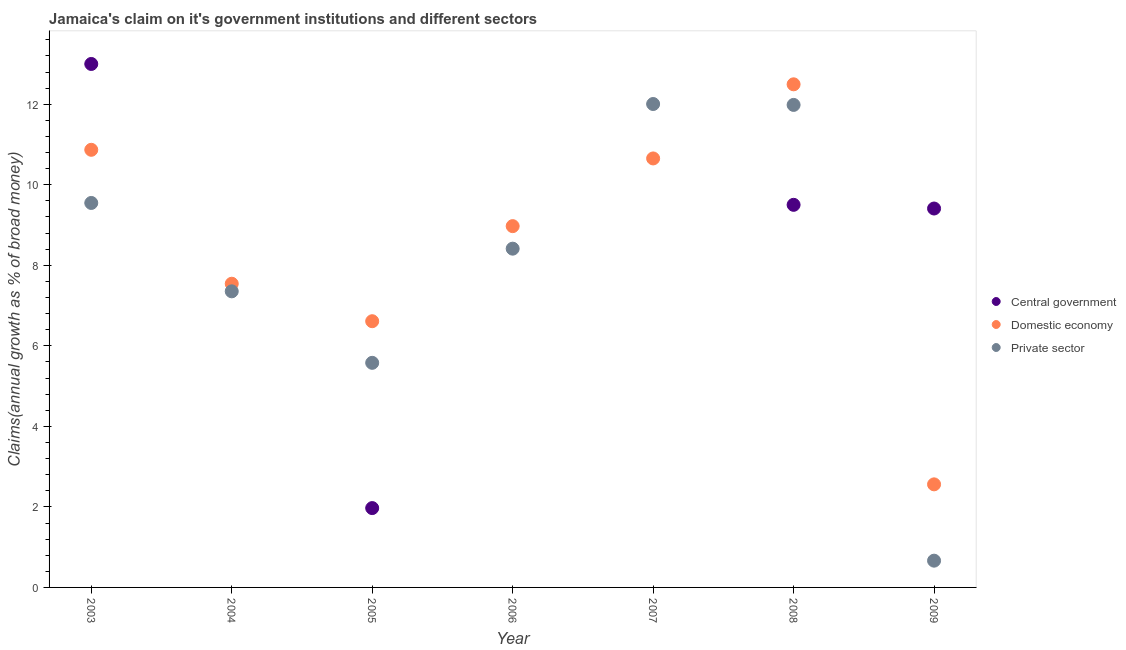Is the number of dotlines equal to the number of legend labels?
Your response must be concise. No. Across all years, what is the maximum percentage of claim on the domestic economy?
Provide a succinct answer. 12.49. Across all years, what is the minimum percentage of claim on the private sector?
Keep it short and to the point. 0.66. In which year was the percentage of claim on the private sector maximum?
Keep it short and to the point. 2007. What is the total percentage of claim on the central government in the graph?
Your response must be concise. 33.88. What is the difference between the percentage of claim on the private sector in 2004 and that in 2007?
Give a very brief answer. -4.65. What is the difference between the percentage of claim on the central government in 2009 and the percentage of claim on the private sector in 2008?
Your answer should be very brief. -2.57. What is the average percentage of claim on the private sector per year?
Give a very brief answer. 7.94. In the year 2008, what is the difference between the percentage of claim on the domestic economy and percentage of claim on the private sector?
Give a very brief answer. 0.51. In how many years, is the percentage of claim on the central government greater than 0.4 %?
Provide a short and direct response. 4. What is the ratio of the percentage of claim on the private sector in 2007 to that in 2008?
Your response must be concise. 1. Is the difference between the percentage of claim on the private sector in 2004 and 2007 greater than the difference between the percentage of claim on the domestic economy in 2004 and 2007?
Offer a very short reply. No. What is the difference between the highest and the second highest percentage of claim on the central government?
Offer a very short reply. 3.5. What is the difference between the highest and the lowest percentage of claim on the private sector?
Offer a terse response. 11.34. In how many years, is the percentage of claim on the domestic economy greater than the average percentage of claim on the domestic economy taken over all years?
Make the answer very short. 4. Is the sum of the percentage of claim on the domestic economy in 2006 and 2007 greater than the maximum percentage of claim on the central government across all years?
Make the answer very short. Yes. Is it the case that in every year, the sum of the percentage of claim on the central government and percentage of claim on the domestic economy is greater than the percentage of claim on the private sector?
Your response must be concise. No. Is the percentage of claim on the private sector strictly less than the percentage of claim on the central government over the years?
Your answer should be compact. No. How many years are there in the graph?
Give a very brief answer. 7. Are the values on the major ticks of Y-axis written in scientific E-notation?
Your answer should be compact. No. Does the graph contain any zero values?
Your answer should be compact. Yes. Does the graph contain grids?
Offer a very short reply. No. Where does the legend appear in the graph?
Make the answer very short. Center right. How are the legend labels stacked?
Your answer should be very brief. Vertical. What is the title of the graph?
Provide a succinct answer. Jamaica's claim on it's government institutions and different sectors. Does "Argument" appear as one of the legend labels in the graph?
Your answer should be compact. No. What is the label or title of the Y-axis?
Offer a terse response. Claims(annual growth as % of broad money). What is the Claims(annual growth as % of broad money) in Central government in 2003?
Your response must be concise. 13. What is the Claims(annual growth as % of broad money) of Domestic economy in 2003?
Offer a very short reply. 10.87. What is the Claims(annual growth as % of broad money) of Private sector in 2003?
Make the answer very short. 9.55. What is the Claims(annual growth as % of broad money) in Central government in 2004?
Make the answer very short. 0. What is the Claims(annual growth as % of broad money) of Domestic economy in 2004?
Make the answer very short. 7.54. What is the Claims(annual growth as % of broad money) in Private sector in 2004?
Ensure brevity in your answer.  7.35. What is the Claims(annual growth as % of broad money) in Central government in 2005?
Offer a very short reply. 1.97. What is the Claims(annual growth as % of broad money) of Domestic economy in 2005?
Provide a short and direct response. 6.61. What is the Claims(annual growth as % of broad money) in Private sector in 2005?
Your response must be concise. 5.58. What is the Claims(annual growth as % of broad money) of Domestic economy in 2006?
Give a very brief answer. 8.97. What is the Claims(annual growth as % of broad money) of Private sector in 2006?
Your answer should be compact. 8.41. What is the Claims(annual growth as % of broad money) of Domestic economy in 2007?
Provide a succinct answer. 10.65. What is the Claims(annual growth as % of broad money) of Private sector in 2007?
Make the answer very short. 12.01. What is the Claims(annual growth as % of broad money) in Central government in 2008?
Make the answer very short. 9.5. What is the Claims(annual growth as % of broad money) of Domestic economy in 2008?
Your answer should be very brief. 12.49. What is the Claims(annual growth as % of broad money) in Private sector in 2008?
Your answer should be compact. 11.98. What is the Claims(annual growth as % of broad money) in Central government in 2009?
Your answer should be compact. 9.41. What is the Claims(annual growth as % of broad money) of Domestic economy in 2009?
Provide a succinct answer. 2.56. What is the Claims(annual growth as % of broad money) of Private sector in 2009?
Provide a succinct answer. 0.66. Across all years, what is the maximum Claims(annual growth as % of broad money) of Central government?
Keep it short and to the point. 13. Across all years, what is the maximum Claims(annual growth as % of broad money) of Domestic economy?
Your answer should be compact. 12.49. Across all years, what is the maximum Claims(annual growth as % of broad money) of Private sector?
Your response must be concise. 12.01. Across all years, what is the minimum Claims(annual growth as % of broad money) of Central government?
Give a very brief answer. 0. Across all years, what is the minimum Claims(annual growth as % of broad money) in Domestic economy?
Offer a very short reply. 2.56. Across all years, what is the minimum Claims(annual growth as % of broad money) of Private sector?
Ensure brevity in your answer.  0.66. What is the total Claims(annual growth as % of broad money) in Central government in the graph?
Your answer should be compact. 33.88. What is the total Claims(annual growth as % of broad money) of Domestic economy in the graph?
Provide a short and direct response. 59.7. What is the total Claims(annual growth as % of broad money) in Private sector in the graph?
Provide a succinct answer. 55.55. What is the difference between the Claims(annual growth as % of broad money) of Domestic economy in 2003 and that in 2004?
Your response must be concise. 3.33. What is the difference between the Claims(annual growth as % of broad money) in Private sector in 2003 and that in 2004?
Your answer should be compact. 2.19. What is the difference between the Claims(annual growth as % of broad money) of Central government in 2003 and that in 2005?
Keep it short and to the point. 11.03. What is the difference between the Claims(annual growth as % of broad money) in Domestic economy in 2003 and that in 2005?
Offer a terse response. 4.26. What is the difference between the Claims(annual growth as % of broad money) of Private sector in 2003 and that in 2005?
Give a very brief answer. 3.97. What is the difference between the Claims(annual growth as % of broad money) of Domestic economy in 2003 and that in 2006?
Your answer should be compact. 1.9. What is the difference between the Claims(annual growth as % of broad money) of Private sector in 2003 and that in 2006?
Give a very brief answer. 1.14. What is the difference between the Claims(annual growth as % of broad money) of Domestic economy in 2003 and that in 2007?
Ensure brevity in your answer.  0.21. What is the difference between the Claims(annual growth as % of broad money) of Private sector in 2003 and that in 2007?
Offer a very short reply. -2.46. What is the difference between the Claims(annual growth as % of broad money) of Central government in 2003 and that in 2008?
Your response must be concise. 3.5. What is the difference between the Claims(annual growth as % of broad money) of Domestic economy in 2003 and that in 2008?
Offer a terse response. -1.63. What is the difference between the Claims(annual growth as % of broad money) of Private sector in 2003 and that in 2008?
Ensure brevity in your answer.  -2.43. What is the difference between the Claims(annual growth as % of broad money) in Central government in 2003 and that in 2009?
Your answer should be compact. 3.59. What is the difference between the Claims(annual growth as % of broad money) in Domestic economy in 2003 and that in 2009?
Provide a succinct answer. 8.31. What is the difference between the Claims(annual growth as % of broad money) in Private sector in 2003 and that in 2009?
Offer a very short reply. 8.88. What is the difference between the Claims(annual growth as % of broad money) of Domestic economy in 2004 and that in 2005?
Make the answer very short. 0.93. What is the difference between the Claims(annual growth as % of broad money) of Private sector in 2004 and that in 2005?
Your answer should be compact. 1.78. What is the difference between the Claims(annual growth as % of broad money) of Domestic economy in 2004 and that in 2006?
Keep it short and to the point. -1.43. What is the difference between the Claims(annual growth as % of broad money) in Private sector in 2004 and that in 2006?
Offer a very short reply. -1.06. What is the difference between the Claims(annual growth as % of broad money) of Domestic economy in 2004 and that in 2007?
Provide a succinct answer. -3.11. What is the difference between the Claims(annual growth as % of broad money) of Private sector in 2004 and that in 2007?
Your response must be concise. -4.65. What is the difference between the Claims(annual growth as % of broad money) of Domestic economy in 2004 and that in 2008?
Provide a short and direct response. -4.95. What is the difference between the Claims(annual growth as % of broad money) in Private sector in 2004 and that in 2008?
Provide a succinct answer. -4.63. What is the difference between the Claims(annual growth as % of broad money) of Domestic economy in 2004 and that in 2009?
Offer a terse response. 4.98. What is the difference between the Claims(annual growth as % of broad money) in Private sector in 2004 and that in 2009?
Offer a very short reply. 6.69. What is the difference between the Claims(annual growth as % of broad money) of Domestic economy in 2005 and that in 2006?
Your response must be concise. -2.36. What is the difference between the Claims(annual growth as % of broad money) in Private sector in 2005 and that in 2006?
Make the answer very short. -2.84. What is the difference between the Claims(annual growth as % of broad money) in Domestic economy in 2005 and that in 2007?
Keep it short and to the point. -4.04. What is the difference between the Claims(annual growth as % of broad money) of Private sector in 2005 and that in 2007?
Make the answer very short. -6.43. What is the difference between the Claims(annual growth as % of broad money) of Central government in 2005 and that in 2008?
Offer a terse response. -7.53. What is the difference between the Claims(annual growth as % of broad money) in Domestic economy in 2005 and that in 2008?
Your answer should be compact. -5.88. What is the difference between the Claims(annual growth as % of broad money) in Private sector in 2005 and that in 2008?
Your answer should be compact. -6.41. What is the difference between the Claims(annual growth as % of broad money) in Central government in 2005 and that in 2009?
Offer a very short reply. -7.44. What is the difference between the Claims(annual growth as % of broad money) in Domestic economy in 2005 and that in 2009?
Provide a succinct answer. 4.05. What is the difference between the Claims(annual growth as % of broad money) of Private sector in 2005 and that in 2009?
Offer a terse response. 4.91. What is the difference between the Claims(annual growth as % of broad money) in Domestic economy in 2006 and that in 2007?
Make the answer very short. -1.68. What is the difference between the Claims(annual growth as % of broad money) in Private sector in 2006 and that in 2007?
Offer a terse response. -3.59. What is the difference between the Claims(annual growth as % of broad money) of Domestic economy in 2006 and that in 2008?
Ensure brevity in your answer.  -3.52. What is the difference between the Claims(annual growth as % of broad money) of Private sector in 2006 and that in 2008?
Provide a short and direct response. -3.57. What is the difference between the Claims(annual growth as % of broad money) of Domestic economy in 2006 and that in 2009?
Give a very brief answer. 6.41. What is the difference between the Claims(annual growth as % of broad money) in Private sector in 2006 and that in 2009?
Make the answer very short. 7.75. What is the difference between the Claims(annual growth as % of broad money) in Domestic economy in 2007 and that in 2008?
Provide a short and direct response. -1.84. What is the difference between the Claims(annual growth as % of broad money) of Private sector in 2007 and that in 2008?
Offer a terse response. 0.02. What is the difference between the Claims(annual growth as % of broad money) of Domestic economy in 2007 and that in 2009?
Keep it short and to the point. 8.09. What is the difference between the Claims(annual growth as % of broad money) in Private sector in 2007 and that in 2009?
Offer a very short reply. 11.34. What is the difference between the Claims(annual growth as % of broad money) in Central government in 2008 and that in 2009?
Your answer should be compact. 0.09. What is the difference between the Claims(annual growth as % of broad money) in Domestic economy in 2008 and that in 2009?
Your answer should be very brief. 9.93. What is the difference between the Claims(annual growth as % of broad money) of Private sector in 2008 and that in 2009?
Provide a short and direct response. 11.32. What is the difference between the Claims(annual growth as % of broad money) of Central government in 2003 and the Claims(annual growth as % of broad money) of Domestic economy in 2004?
Ensure brevity in your answer.  5.46. What is the difference between the Claims(annual growth as % of broad money) of Central government in 2003 and the Claims(annual growth as % of broad money) of Private sector in 2004?
Offer a terse response. 5.65. What is the difference between the Claims(annual growth as % of broad money) in Domestic economy in 2003 and the Claims(annual growth as % of broad money) in Private sector in 2004?
Give a very brief answer. 3.51. What is the difference between the Claims(annual growth as % of broad money) of Central government in 2003 and the Claims(annual growth as % of broad money) of Domestic economy in 2005?
Make the answer very short. 6.39. What is the difference between the Claims(annual growth as % of broad money) of Central government in 2003 and the Claims(annual growth as % of broad money) of Private sector in 2005?
Keep it short and to the point. 7.42. What is the difference between the Claims(annual growth as % of broad money) of Domestic economy in 2003 and the Claims(annual growth as % of broad money) of Private sector in 2005?
Ensure brevity in your answer.  5.29. What is the difference between the Claims(annual growth as % of broad money) of Central government in 2003 and the Claims(annual growth as % of broad money) of Domestic economy in 2006?
Keep it short and to the point. 4.03. What is the difference between the Claims(annual growth as % of broad money) in Central government in 2003 and the Claims(annual growth as % of broad money) in Private sector in 2006?
Your answer should be compact. 4.59. What is the difference between the Claims(annual growth as % of broad money) in Domestic economy in 2003 and the Claims(annual growth as % of broad money) in Private sector in 2006?
Give a very brief answer. 2.46. What is the difference between the Claims(annual growth as % of broad money) of Central government in 2003 and the Claims(annual growth as % of broad money) of Domestic economy in 2007?
Offer a terse response. 2.35. What is the difference between the Claims(annual growth as % of broad money) in Domestic economy in 2003 and the Claims(annual growth as % of broad money) in Private sector in 2007?
Offer a very short reply. -1.14. What is the difference between the Claims(annual growth as % of broad money) of Central government in 2003 and the Claims(annual growth as % of broad money) of Domestic economy in 2008?
Offer a terse response. 0.51. What is the difference between the Claims(annual growth as % of broad money) of Central government in 2003 and the Claims(annual growth as % of broad money) of Private sector in 2008?
Make the answer very short. 1.02. What is the difference between the Claims(annual growth as % of broad money) of Domestic economy in 2003 and the Claims(annual growth as % of broad money) of Private sector in 2008?
Ensure brevity in your answer.  -1.11. What is the difference between the Claims(annual growth as % of broad money) of Central government in 2003 and the Claims(annual growth as % of broad money) of Domestic economy in 2009?
Your response must be concise. 10.44. What is the difference between the Claims(annual growth as % of broad money) in Central government in 2003 and the Claims(annual growth as % of broad money) in Private sector in 2009?
Provide a succinct answer. 12.34. What is the difference between the Claims(annual growth as % of broad money) of Domestic economy in 2003 and the Claims(annual growth as % of broad money) of Private sector in 2009?
Your answer should be compact. 10.2. What is the difference between the Claims(annual growth as % of broad money) in Domestic economy in 2004 and the Claims(annual growth as % of broad money) in Private sector in 2005?
Provide a short and direct response. 1.96. What is the difference between the Claims(annual growth as % of broad money) in Domestic economy in 2004 and the Claims(annual growth as % of broad money) in Private sector in 2006?
Keep it short and to the point. -0.87. What is the difference between the Claims(annual growth as % of broad money) of Domestic economy in 2004 and the Claims(annual growth as % of broad money) of Private sector in 2007?
Make the answer very short. -4.46. What is the difference between the Claims(annual growth as % of broad money) in Domestic economy in 2004 and the Claims(annual growth as % of broad money) in Private sector in 2008?
Ensure brevity in your answer.  -4.44. What is the difference between the Claims(annual growth as % of broad money) of Domestic economy in 2004 and the Claims(annual growth as % of broad money) of Private sector in 2009?
Provide a succinct answer. 6.88. What is the difference between the Claims(annual growth as % of broad money) of Central government in 2005 and the Claims(annual growth as % of broad money) of Domestic economy in 2006?
Your answer should be compact. -7. What is the difference between the Claims(annual growth as % of broad money) in Central government in 2005 and the Claims(annual growth as % of broad money) in Private sector in 2006?
Make the answer very short. -6.44. What is the difference between the Claims(annual growth as % of broad money) of Domestic economy in 2005 and the Claims(annual growth as % of broad money) of Private sector in 2006?
Offer a very short reply. -1.8. What is the difference between the Claims(annual growth as % of broad money) in Central government in 2005 and the Claims(annual growth as % of broad money) in Domestic economy in 2007?
Provide a short and direct response. -8.68. What is the difference between the Claims(annual growth as % of broad money) of Central government in 2005 and the Claims(annual growth as % of broad money) of Private sector in 2007?
Your answer should be very brief. -10.04. What is the difference between the Claims(annual growth as % of broad money) of Domestic economy in 2005 and the Claims(annual growth as % of broad money) of Private sector in 2007?
Give a very brief answer. -5.39. What is the difference between the Claims(annual growth as % of broad money) in Central government in 2005 and the Claims(annual growth as % of broad money) in Domestic economy in 2008?
Your answer should be very brief. -10.52. What is the difference between the Claims(annual growth as % of broad money) in Central government in 2005 and the Claims(annual growth as % of broad money) in Private sector in 2008?
Ensure brevity in your answer.  -10.01. What is the difference between the Claims(annual growth as % of broad money) of Domestic economy in 2005 and the Claims(annual growth as % of broad money) of Private sector in 2008?
Make the answer very short. -5.37. What is the difference between the Claims(annual growth as % of broad money) of Central government in 2005 and the Claims(annual growth as % of broad money) of Domestic economy in 2009?
Ensure brevity in your answer.  -0.59. What is the difference between the Claims(annual growth as % of broad money) of Central government in 2005 and the Claims(annual growth as % of broad money) of Private sector in 2009?
Ensure brevity in your answer.  1.31. What is the difference between the Claims(annual growth as % of broad money) in Domestic economy in 2005 and the Claims(annual growth as % of broad money) in Private sector in 2009?
Provide a short and direct response. 5.95. What is the difference between the Claims(annual growth as % of broad money) of Domestic economy in 2006 and the Claims(annual growth as % of broad money) of Private sector in 2007?
Your answer should be compact. -3.03. What is the difference between the Claims(annual growth as % of broad money) of Domestic economy in 2006 and the Claims(annual growth as % of broad money) of Private sector in 2008?
Ensure brevity in your answer.  -3.01. What is the difference between the Claims(annual growth as % of broad money) in Domestic economy in 2006 and the Claims(annual growth as % of broad money) in Private sector in 2009?
Provide a short and direct response. 8.31. What is the difference between the Claims(annual growth as % of broad money) of Domestic economy in 2007 and the Claims(annual growth as % of broad money) of Private sector in 2008?
Ensure brevity in your answer.  -1.33. What is the difference between the Claims(annual growth as % of broad money) in Domestic economy in 2007 and the Claims(annual growth as % of broad money) in Private sector in 2009?
Make the answer very short. 9.99. What is the difference between the Claims(annual growth as % of broad money) of Central government in 2008 and the Claims(annual growth as % of broad money) of Domestic economy in 2009?
Provide a short and direct response. 6.94. What is the difference between the Claims(annual growth as % of broad money) in Central government in 2008 and the Claims(annual growth as % of broad money) in Private sector in 2009?
Provide a succinct answer. 8.84. What is the difference between the Claims(annual growth as % of broad money) of Domestic economy in 2008 and the Claims(annual growth as % of broad money) of Private sector in 2009?
Make the answer very short. 11.83. What is the average Claims(annual growth as % of broad money) in Central government per year?
Ensure brevity in your answer.  4.84. What is the average Claims(annual growth as % of broad money) in Domestic economy per year?
Offer a terse response. 8.53. What is the average Claims(annual growth as % of broad money) of Private sector per year?
Offer a very short reply. 7.94. In the year 2003, what is the difference between the Claims(annual growth as % of broad money) of Central government and Claims(annual growth as % of broad money) of Domestic economy?
Provide a succinct answer. 2.13. In the year 2003, what is the difference between the Claims(annual growth as % of broad money) of Central government and Claims(annual growth as % of broad money) of Private sector?
Offer a terse response. 3.45. In the year 2003, what is the difference between the Claims(annual growth as % of broad money) in Domestic economy and Claims(annual growth as % of broad money) in Private sector?
Offer a terse response. 1.32. In the year 2004, what is the difference between the Claims(annual growth as % of broad money) in Domestic economy and Claims(annual growth as % of broad money) in Private sector?
Your response must be concise. 0.19. In the year 2005, what is the difference between the Claims(annual growth as % of broad money) of Central government and Claims(annual growth as % of broad money) of Domestic economy?
Your answer should be compact. -4.64. In the year 2005, what is the difference between the Claims(annual growth as % of broad money) in Central government and Claims(annual growth as % of broad money) in Private sector?
Your response must be concise. -3.61. In the year 2005, what is the difference between the Claims(annual growth as % of broad money) of Domestic economy and Claims(annual growth as % of broad money) of Private sector?
Make the answer very short. 1.03. In the year 2006, what is the difference between the Claims(annual growth as % of broad money) in Domestic economy and Claims(annual growth as % of broad money) in Private sector?
Ensure brevity in your answer.  0.56. In the year 2007, what is the difference between the Claims(annual growth as % of broad money) in Domestic economy and Claims(annual growth as % of broad money) in Private sector?
Ensure brevity in your answer.  -1.35. In the year 2008, what is the difference between the Claims(annual growth as % of broad money) of Central government and Claims(annual growth as % of broad money) of Domestic economy?
Make the answer very short. -2.99. In the year 2008, what is the difference between the Claims(annual growth as % of broad money) in Central government and Claims(annual growth as % of broad money) in Private sector?
Give a very brief answer. -2.48. In the year 2008, what is the difference between the Claims(annual growth as % of broad money) of Domestic economy and Claims(annual growth as % of broad money) of Private sector?
Your answer should be very brief. 0.51. In the year 2009, what is the difference between the Claims(annual growth as % of broad money) in Central government and Claims(annual growth as % of broad money) in Domestic economy?
Offer a very short reply. 6.85. In the year 2009, what is the difference between the Claims(annual growth as % of broad money) of Central government and Claims(annual growth as % of broad money) of Private sector?
Offer a terse response. 8.75. In the year 2009, what is the difference between the Claims(annual growth as % of broad money) in Domestic economy and Claims(annual growth as % of broad money) in Private sector?
Give a very brief answer. 1.9. What is the ratio of the Claims(annual growth as % of broad money) in Domestic economy in 2003 to that in 2004?
Offer a very short reply. 1.44. What is the ratio of the Claims(annual growth as % of broad money) in Private sector in 2003 to that in 2004?
Keep it short and to the point. 1.3. What is the ratio of the Claims(annual growth as % of broad money) in Central government in 2003 to that in 2005?
Offer a terse response. 6.6. What is the ratio of the Claims(annual growth as % of broad money) of Domestic economy in 2003 to that in 2005?
Make the answer very short. 1.64. What is the ratio of the Claims(annual growth as % of broad money) of Private sector in 2003 to that in 2005?
Your answer should be compact. 1.71. What is the ratio of the Claims(annual growth as % of broad money) in Domestic economy in 2003 to that in 2006?
Make the answer very short. 1.21. What is the ratio of the Claims(annual growth as % of broad money) in Private sector in 2003 to that in 2006?
Make the answer very short. 1.13. What is the ratio of the Claims(annual growth as % of broad money) of Domestic economy in 2003 to that in 2007?
Give a very brief answer. 1.02. What is the ratio of the Claims(annual growth as % of broad money) of Private sector in 2003 to that in 2007?
Provide a short and direct response. 0.8. What is the ratio of the Claims(annual growth as % of broad money) of Central government in 2003 to that in 2008?
Your answer should be very brief. 1.37. What is the ratio of the Claims(annual growth as % of broad money) of Domestic economy in 2003 to that in 2008?
Offer a very short reply. 0.87. What is the ratio of the Claims(annual growth as % of broad money) of Private sector in 2003 to that in 2008?
Ensure brevity in your answer.  0.8. What is the ratio of the Claims(annual growth as % of broad money) in Central government in 2003 to that in 2009?
Provide a short and direct response. 1.38. What is the ratio of the Claims(annual growth as % of broad money) of Domestic economy in 2003 to that in 2009?
Your response must be concise. 4.25. What is the ratio of the Claims(annual growth as % of broad money) of Private sector in 2003 to that in 2009?
Your answer should be very brief. 14.37. What is the ratio of the Claims(annual growth as % of broad money) of Domestic economy in 2004 to that in 2005?
Your answer should be very brief. 1.14. What is the ratio of the Claims(annual growth as % of broad money) of Private sector in 2004 to that in 2005?
Give a very brief answer. 1.32. What is the ratio of the Claims(annual growth as % of broad money) of Domestic economy in 2004 to that in 2006?
Ensure brevity in your answer.  0.84. What is the ratio of the Claims(annual growth as % of broad money) of Private sector in 2004 to that in 2006?
Provide a succinct answer. 0.87. What is the ratio of the Claims(annual growth as % of broad money) in Domestic economy in 2004 to that in 2007?
Provide a short and direct response. 0.71. What is the ratio of the Claims(annual growth as % of broad money) in Private sector in 2004 to that in 2007?
Offer a very short reply. 0.61. What is the ratio of the Claims(annual growth as % of broad money) of Domestic economy in 2004 to that in 2008?
Ensure brevity in your answer.  0.6. What is the ratio of the Claims(annual growth as % of broad money) in Private sector in 2004 to that in 2008?
Give a very brief answer. 0.61. What is the ratio of the Claims(annual growth as % of broad money) in Domestic economy in 2004 to that in 2009?
Your answer should be very brief. 2.95. What is the ratio of the Claims(annual growth as % of broad money) in Private sector in 2004 to that in 2009?
Your answer should be very brief. 11.07. What is the ratio of the Claims(annual growth as % of broad money) of Domestic economy in 2005 to that in 2006?
Offer a terse response. 0.74. What is the ratio of the Claims(annual growth as % of broad money) in Private sector in 2005 to that in 2006?
Your response must be concise. 0.66. What is the ratio of the Claims(annual growth as % of broad money) in Domestic economy in 2005 to that in 2007?
Give a very brief answer. 0.62. What is the ratio of the Claims(annual growth as % of broad money) of Private sector in 2005 to that in 2007?
Ensure brevity in your answer.  0.46. What is the ratio of the Claims(annual growth as % of broad money) in Central government in 2005 to that in 2008?
Your answer should be very brief. 0.21. What is the ratio of the Claims(annual growth as % of broad money) of Domestic economy in 2005 to that in 2008?
Give a very brief answer. 0.53. What is the ratio of the Claims(annual growth as % of broad money) in Private sector in 2005 to that in 2008?
Your answer should be compact. 0.47. What is the ratio of the Claims(annual growth as % of broad money) of Central government in 2005 to that in 2009?
Your answer should be very brief. 0.21. What is the ratio of the Claims(annual growth as % of broad money) in Domestic economy in 2005 to that in 2009?
Offer a terse response. 2.58. What is the ratio of the Claims(annual growth as % of broad money) of Private sector in 2005 to that in 2009?
Your response must be concise. 8.39. What is the ratio of the Claims(annual growth as % of broad money) of Domestic economy in 2006 to that in 2007?
Make the answer very short. 0.84. What is the ratio of the Claims(annual growth as % of broad money) of Private sector in 2006 to that in 2007?
Provide a succinct answer. 0.7. What is the ratio of the Claims(annual growth as % of broad money) in Domestic economy in 2006 to that in 2008?
Your answer should be compact. 0.72. What is the ratio of the Claims(annual growth as % of broad money) of Private sector in 2006 to that in 2008?
Your answer should be very brief. 0.7. What is the ratio of the Claims(annual growth as % of broad money) in Domestic economy in 2006 to that in 2009?
Give a very brief answer. 3.51. What is the ratio of the Claims(annual growth as % of broad money) of Private sector in 2006 to that in 2009?
Offer a terse response. 12.66. What is the ratio of the Claims(annual growth as % of broad money) of Domestic economy in 2007 to that in 2008?
Your response must be concise. 0.85. What is the ratio of the Claims(annual growth as % of broad money) of Private sector in 2007 to that in 2008?
Make the answer very short. 1. What is the ratio of the Claims(annual growth as % of broad money) of Domestic economy in 2007 to that in 2009?
Provide a succinct answer. 4.16. What is the ratio of the Claims(annual growth as % of broad money) of Private sector in 2007 to that in 2009?
Make the answer very short. 18.07. What is the ratio of the Claims(annual growth as % of broad money) in Central government in 2008 to that in 2009?
Provide a short and direct response. 1.01. What is the ratio of the Claims(annual growth as % of broad money) of Domestic economy in 2008 to that in 2009?
Offer a very short reply. 4.88. What is the ratio of the Claims(annual growth as % of broad money) in Private sector in 2008 to that in 2009?
Make the answer very short. 18.03. What is the difference between the highest and the second highest Claims(annual growth as % of broad money) in Central government?
Your answer should be compact. 3.5. What is the difference between the highest and the second highest Claims(annual growth as % of broad money) of Domestic economy?
Your response must be concise. 1.63. What is the difference between the highest and the second highest Claims(annual growth as % of broad money) in Private sector?
Offer a terse response. 0.02. What is the difference between the highest and the lowest Claims(annual growth as % of broad money) of Central government?
Ensure brevity in your answer.  13. What is the difference between the highest and the lowest Claims(annual growth as % of broad money) of Domestic economy?
Keep it short and to the point. 9.93. What is the difference between the highest and the lowest Claims(annual growth as % of broad money) of Private sector?
Your answer should be compact. 11.34. 